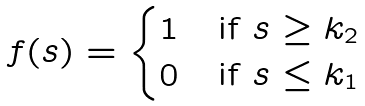Convert formula to latex. <formula><loc_0><loc_0><loc_500><loc_500>\begin{array} { c l } f ( s ) = \begin{cases} 1 & \text {if $s\geq k_{2}$} \\ 0 & \text {if $s\leq k_{1}$} \end{cases} \end{array}</formula> 